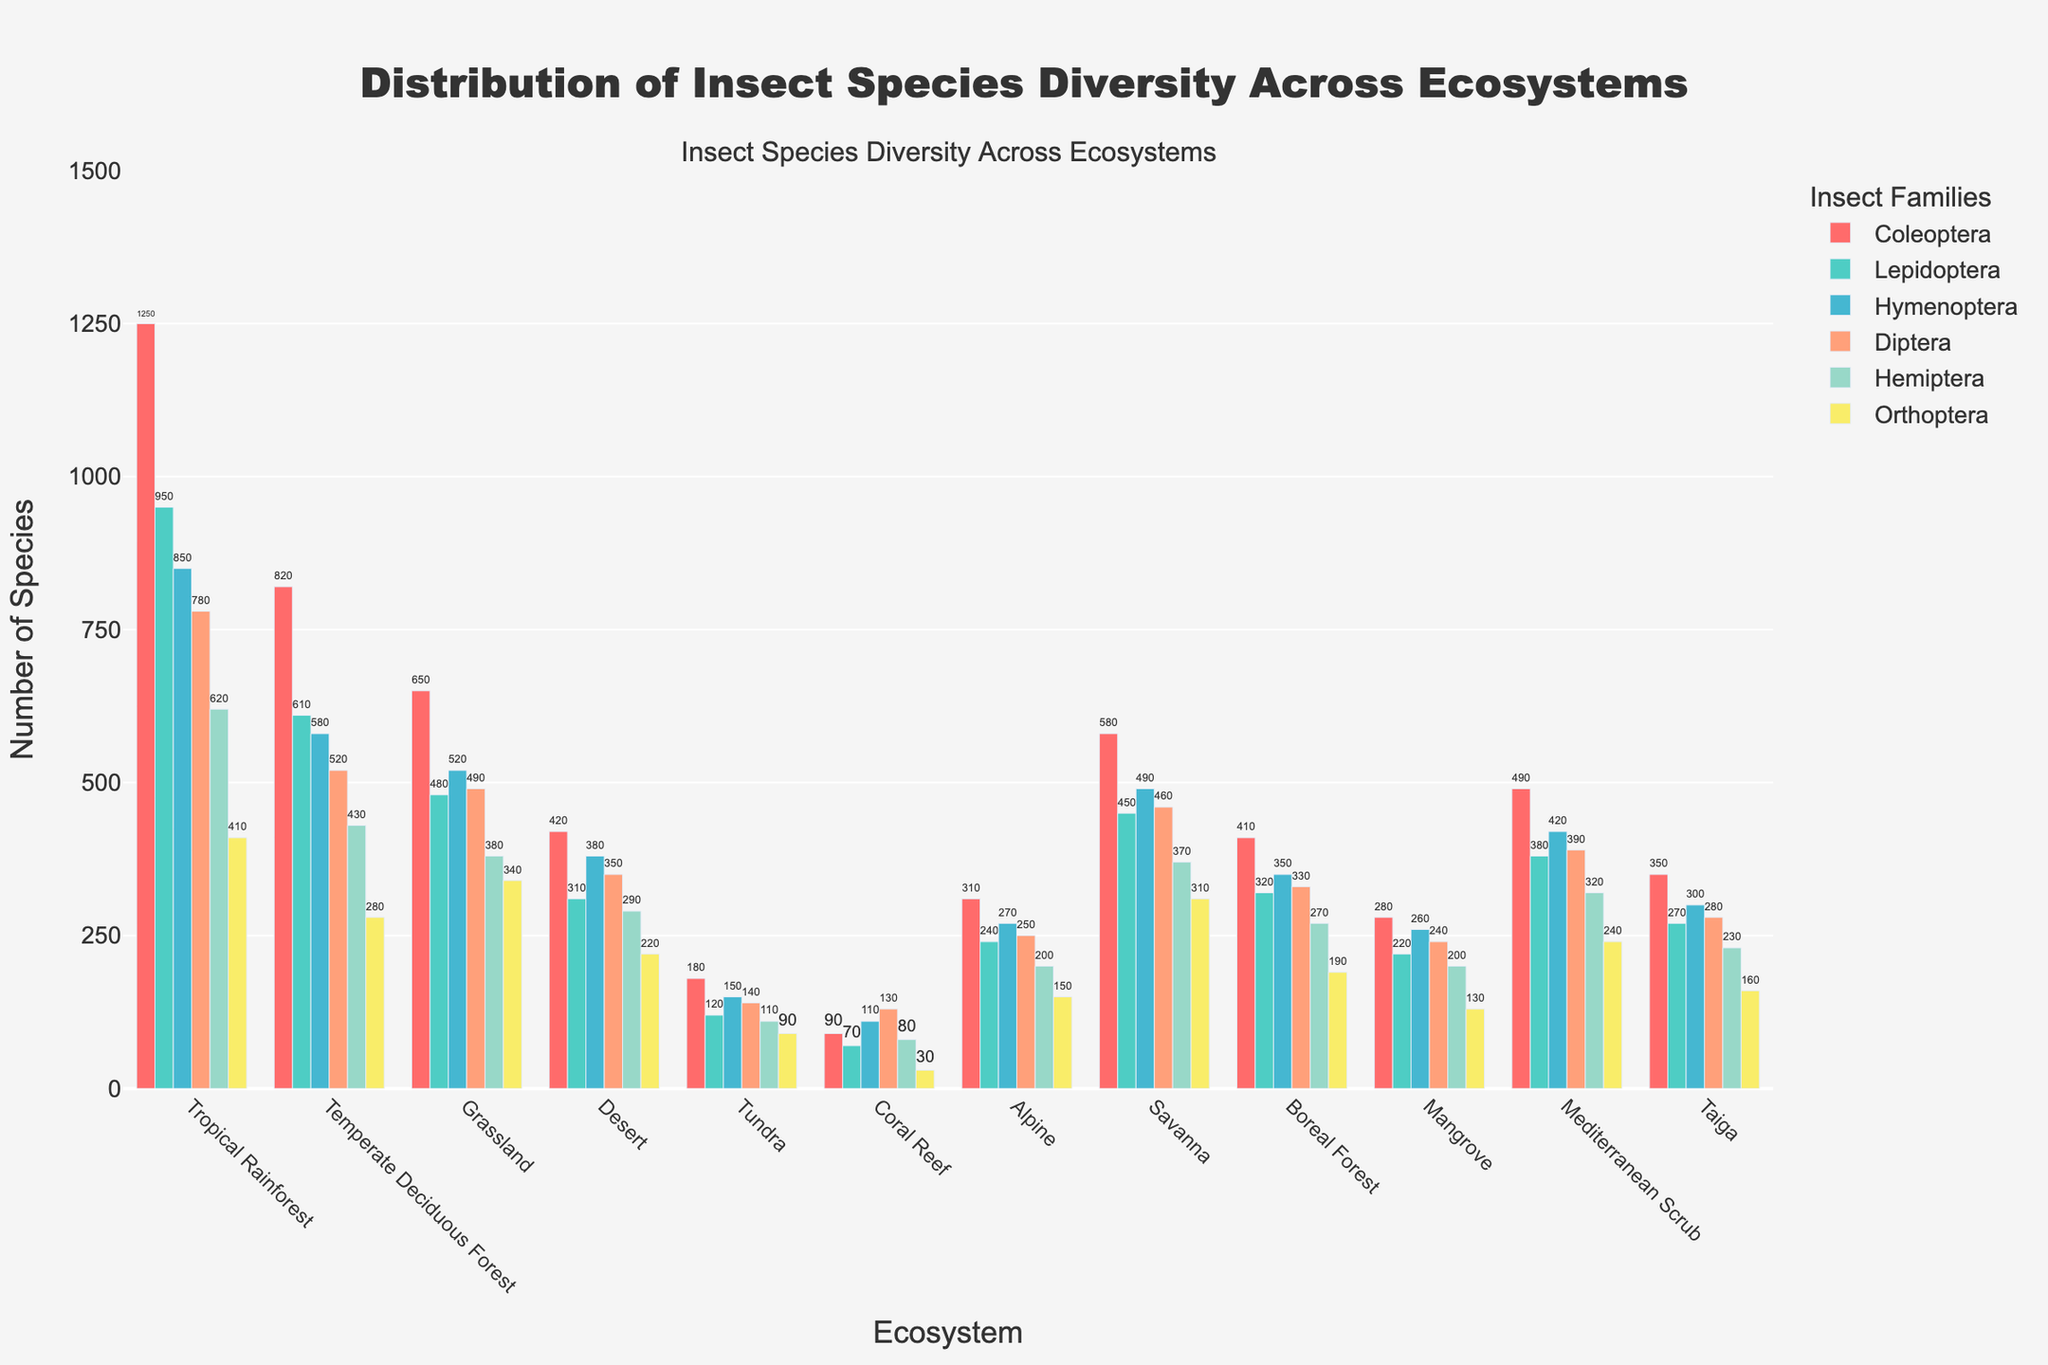What is the total number of Coleoptera species in the Tropical Rainforest and Temperate Deciduous Forest? Add the number of Coleoptera species in both ecosystems: 1250 (Tropical Rainforest) + 820 (Temperate Deciduous Forest)
Answer: 2070 Which ecosystem has the highest number of Lepidoptera species? Compare the number of Lepidoptera species across all ecosystems and identify the highest value, which is in the Tropical Rainforest with 950 species
Answer: Tropical Rainforest In which ecosystem do Diptera species count surpass Hemiptera species count? Compare the number of Diptera and Hemiptera species for each ecosystem and identify where Diptera counts are higher than Hemiptera: Coral Reef (130 > 80), Mangrove (240 > 200)
Answer: Coral Reef, Mangrove What is the average number of Orthoptera species across all ecosystems? Sum the number of Orthoptera species in all ecosystems and divide by the number of ecosystems: (410 + 280 + 340 + 220 + 90 + 30 + 150 + 310 + 190 + 130 + 240 + 160) / 12
Answer: 220 Which ecosystem has the lowest overall insect species diversity? Add the number of species for all families in each ecosystem and identify the one with the lowest total: Tundra (180 + 120 + 150 + 140 + 110 + 90 = 790)
Answer: Tundra Compare the total insect species diversity in the Alpine ecosystem to that in the Savanna ecosystem. Calculate the total number of species in both ecosystems by summing up species from all families: Alpine (310 + 240 + 270 + 250 + 200 + 150 = 1420) and Savanna (580 + 450 + 490 + 460 + 370 + 310 = 2660)
Answer: Savanna has higher diversity Which taxonomic family shows the least variation in species count across all ecosystems? Evaluate the range (max-min) of species count for each family and select the family with the smallest range: Orthoptera (410 - 30 = 380)
Answer: Orthoptera What is the combined number of Lepidoptera and Hymenoptera species in the Grassland ecosystem? Add the number of Lepidoptera and Hymenoptera species: 480 (Lepidoptera) + 520 (Hymenoptera)
Answer: 1000 Which insect family is visually represented by the tallest bar in the given chart? By inspecting the colors and heights of the bars, the tallest bar represents Coleoptera in the Tropical Rainforest with 1250 species
Answer: Coleoptera Is there any ecosystem where the number of species for Hemiptera is greater than the number of species for Coleoptera? Compare the number of Hemiptera and Coleoptera species in each ecosystem and identify any instances where Hemiptera has more species. No such instance is found
Answer: No 